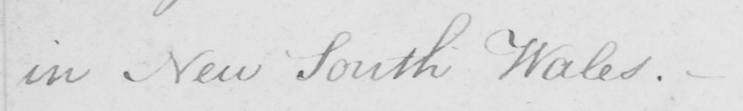What text is written in this handwritten line? in New South Wales . 